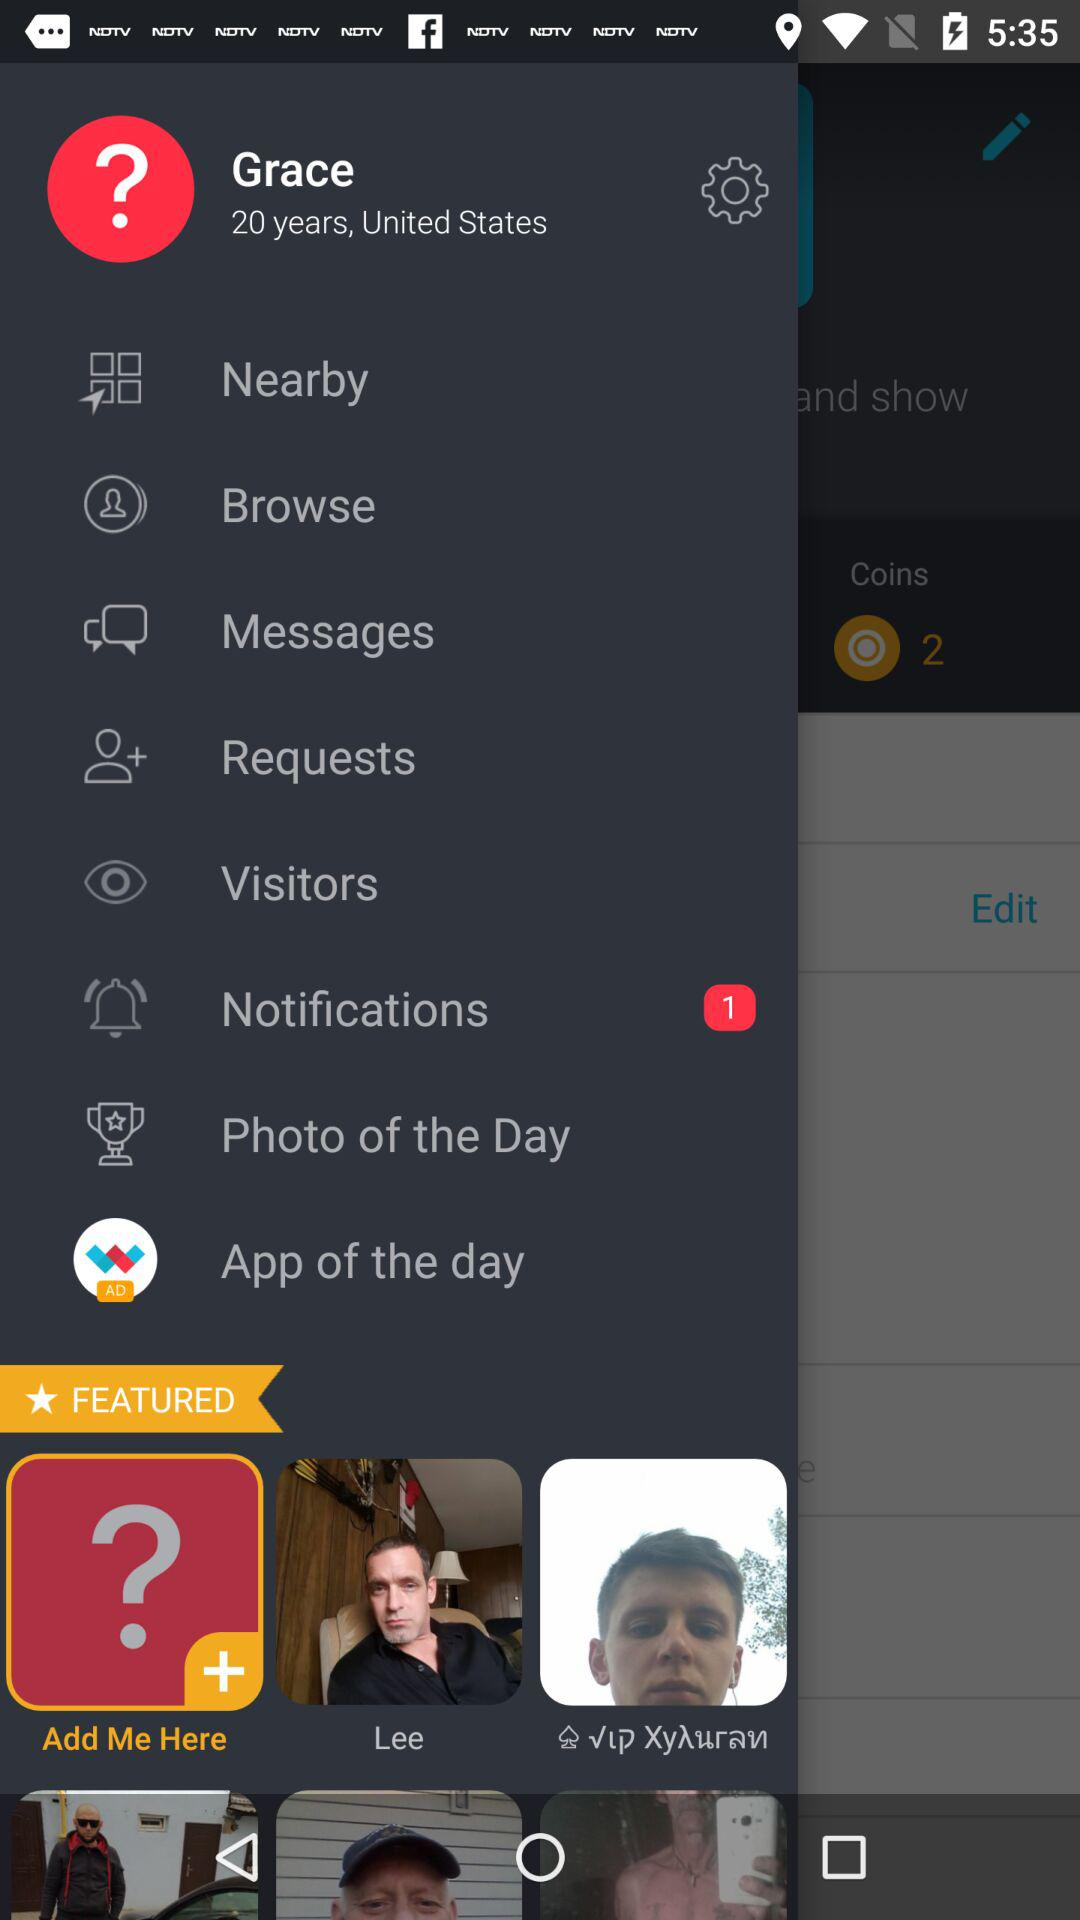What is username?
When the provided information is insufficient, respond with <no answer>. <no answer> 